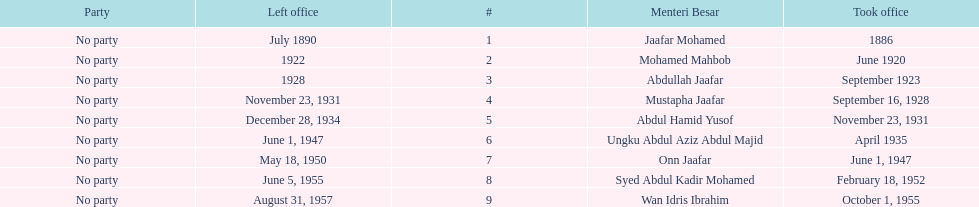Who was in office after mustapha jaafar Abdul Hamid Yusof. 